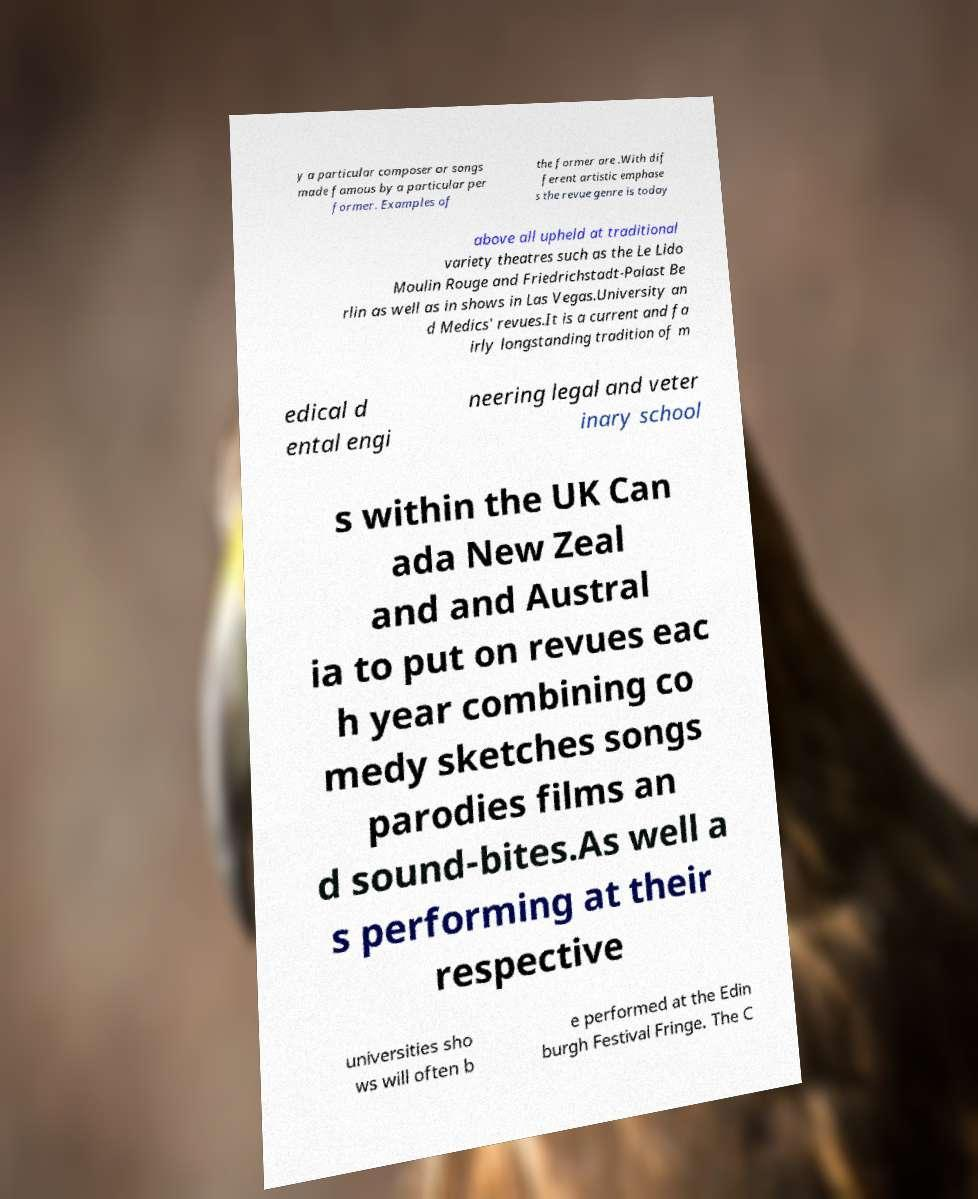Can you read and provide the text displayed in the image?This photo seems to have some interesting text. Can you extract and type it out for me? y a particular composer or songs made famous by a particular per former. Examples of the former are .With dif ferent artistic emphase s the revue genre is today above all upheld at traditional variety theatres such as the Le Lido Moulin Rouge and Friedrichstadt-Palast Be rlin as well as in shows in Las Vegas.University an d Medics' revues.It is a current and fa irly longstanding tradition of m edical d ental engi neering legal and veter inary school s within the UK Can ada New Zeal and and Austral ia to put on revues eac h year combining co medy sketches songs parodies films an d sound-bites.As well a s performing at their respective universities sho ws will often b e performed at the Edin burgh Festival Fringe. The C 